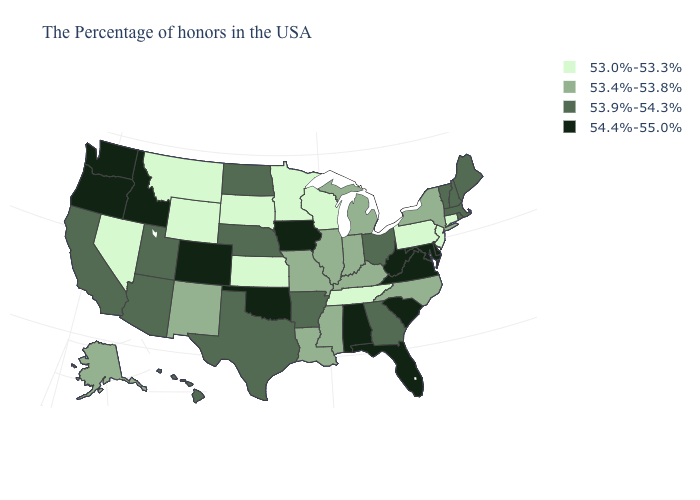Among the states that border Wyoming , which have the lowest value?
Answer briefly. South Dakota, Montana. Which states hav the highest value in the MidWest?
Answer briefly. Iowa. What is the value of Alaska?
Be succinct. 53.4%-53.8%. What is the lowest value in the Northeast?
Keep it brief. 53.0%-53.3%. What is the value of Nebraska?
Quick response, please. 53.9%-54.3%. What is the lowest value in states that border Virginia?
Give a very brief answer. 53.0%-53.3%. Does Georgia have a lower value than Rhode Island?
Quick response, please. No. What is the lowest value in states that border Maine?
Keep it brief. 53.9%-54.3%. Does Mississippi have a higher value than Rhode Island?
Quick response, please. No. Name the states that have a value in the range 53.0%-53.3%?
Quick response, please. Connecticut, New Jersey, Pennsylvania, Tennessee, Wisconsin, Minnesota, Kansas, South Dakota, Wyoming, Montana, Nevada. Does Delaware have the lowest value in the USA?
Give a very brief answer. No. Does Tennessee have the same value as Alabama?
Write a very short answer. No. What is the lowest value in the South?
Write a very short answer. 53.0%-53.3%. Among the states that border New Jersey , does Delaware have the highest value?
Write a very short answer. Yes. What is the value of Indiana?
Short answer required. 53.4%-53.8%. 